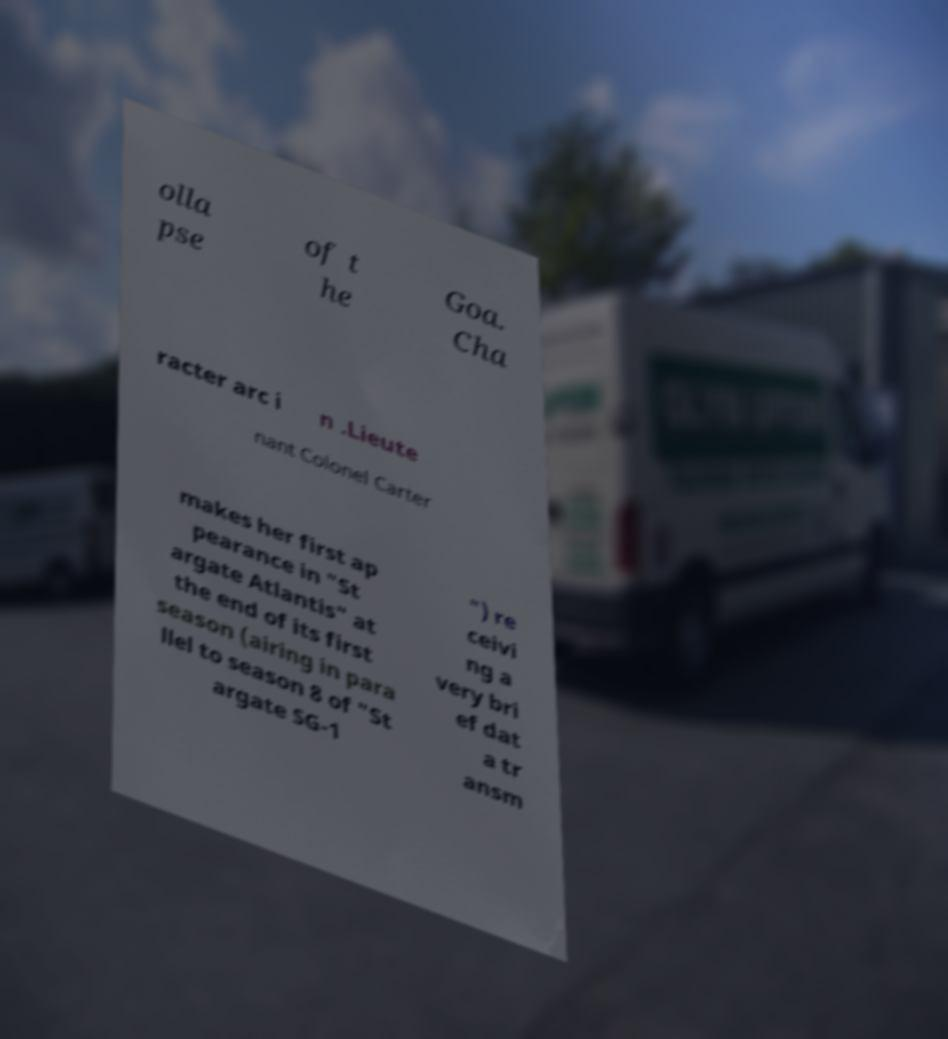Can you read and provide the text displayed in the image?This photo seems to have some interesting text. Can you extract and type it out for me? olla pse of t he Goa. Cha racter arc i n .Lieute nant Colonel Carter makes her first ap pearance in "St argate Atlantis" at the end of its first season (airing in para llel to season 8 of "St argate SG-1 ") re ceivi ng a very bri ef dat a tr ansm 